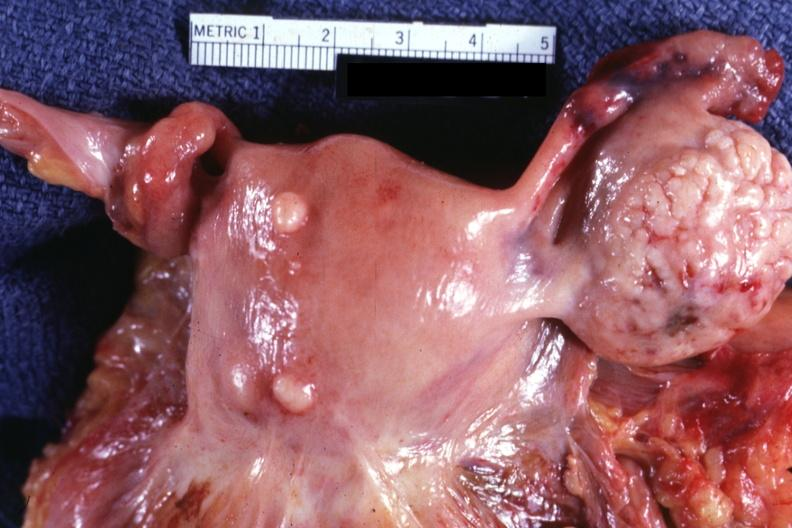how much lesion are small normal ovary is in photo?
Answer the question using a single word or phrase. One 